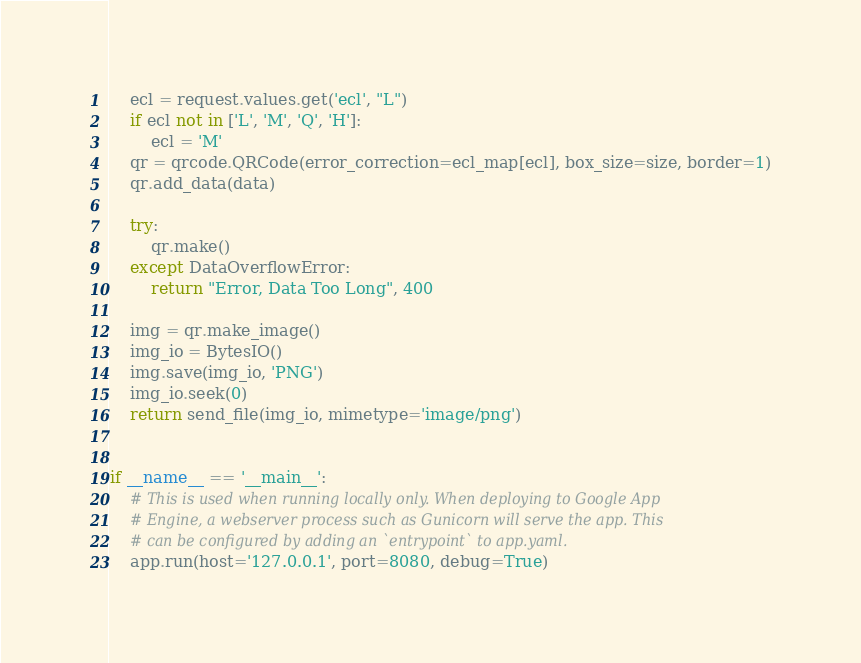<code> <loc_0><loc_0><loc_500><loc_500><_Python_>    ecl = request.values.get('ecl', "L")
    if ecl not in ['L', 'M', 'Q', 'H']:
        ecl = 'M'
    qr = qrcode.QRCode(error_correction=ecl_map[ecl], box_size=size, border=1)
    qr.add_data(data)

    try:
        qr.make()
    except DataOverflowError:
        return "Error, Data Too Long", 400

    img = qr.make_image()
    img_io = BytesIO()
    img.save(img_io, 'PNG')
    img_io.seek(0)
    return send_file(img_io, mimetype='image/png')


if __name__ == '__main__':
    # This is used when running locally only. When deploying to Google App
    # Engine, a webserver process such as Gunicorn will serve the app. This
    # can be configured by adding an `entrypoint` to app.yaml.
    app.run(host='127.0.0.1', port=8080, debug=True)
</code> 